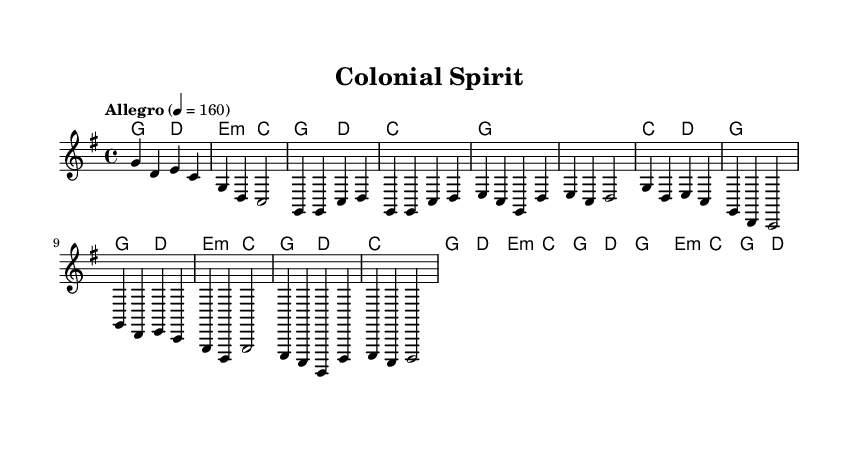What is the key signature of this music? The key signature is G major, which has one sharp (F#).
Answer: G major What is the time signature of this music? The time signature is 4/4, indicating four beats per measure.
Answer: 4/4 What is the tempo marking of this music? The tempo marking is "Allegro" with a metronome marking of 160 beats per minute.
Answer: Allegro, 160 How many measures are in the chorus section? The chorus consists of four measures, as indicated by the musical notation and alignment.
Answer: 4 What is the first chord played in the song? The first chord indicated is G major, as shown in the chord symbols at the beginning.
Answer: G How does the bridge differ from the verse in terms of chord progression? The bridge introduces a different harmonic structure, specifically moving to E minor and G major, while the verse primarily uses G and C major.
Answer: Different harmonic structure What characteristic elements of Country Rock can be seen in this piece? The piece features an upbeat tempo, prominent use of major chords, and a straightforward melodic line that is characteristic of Country Rock.
Answer: Upbeat tempo and major chords 